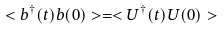Convert formula to latex. <formula><loc_0><loc_0><loc_500><loc_500>< b ^ { \dagger } ( t ) b ( 0 ) > = < U ^ { \dagger } ( t ) U ( 0 ) ></formula> 